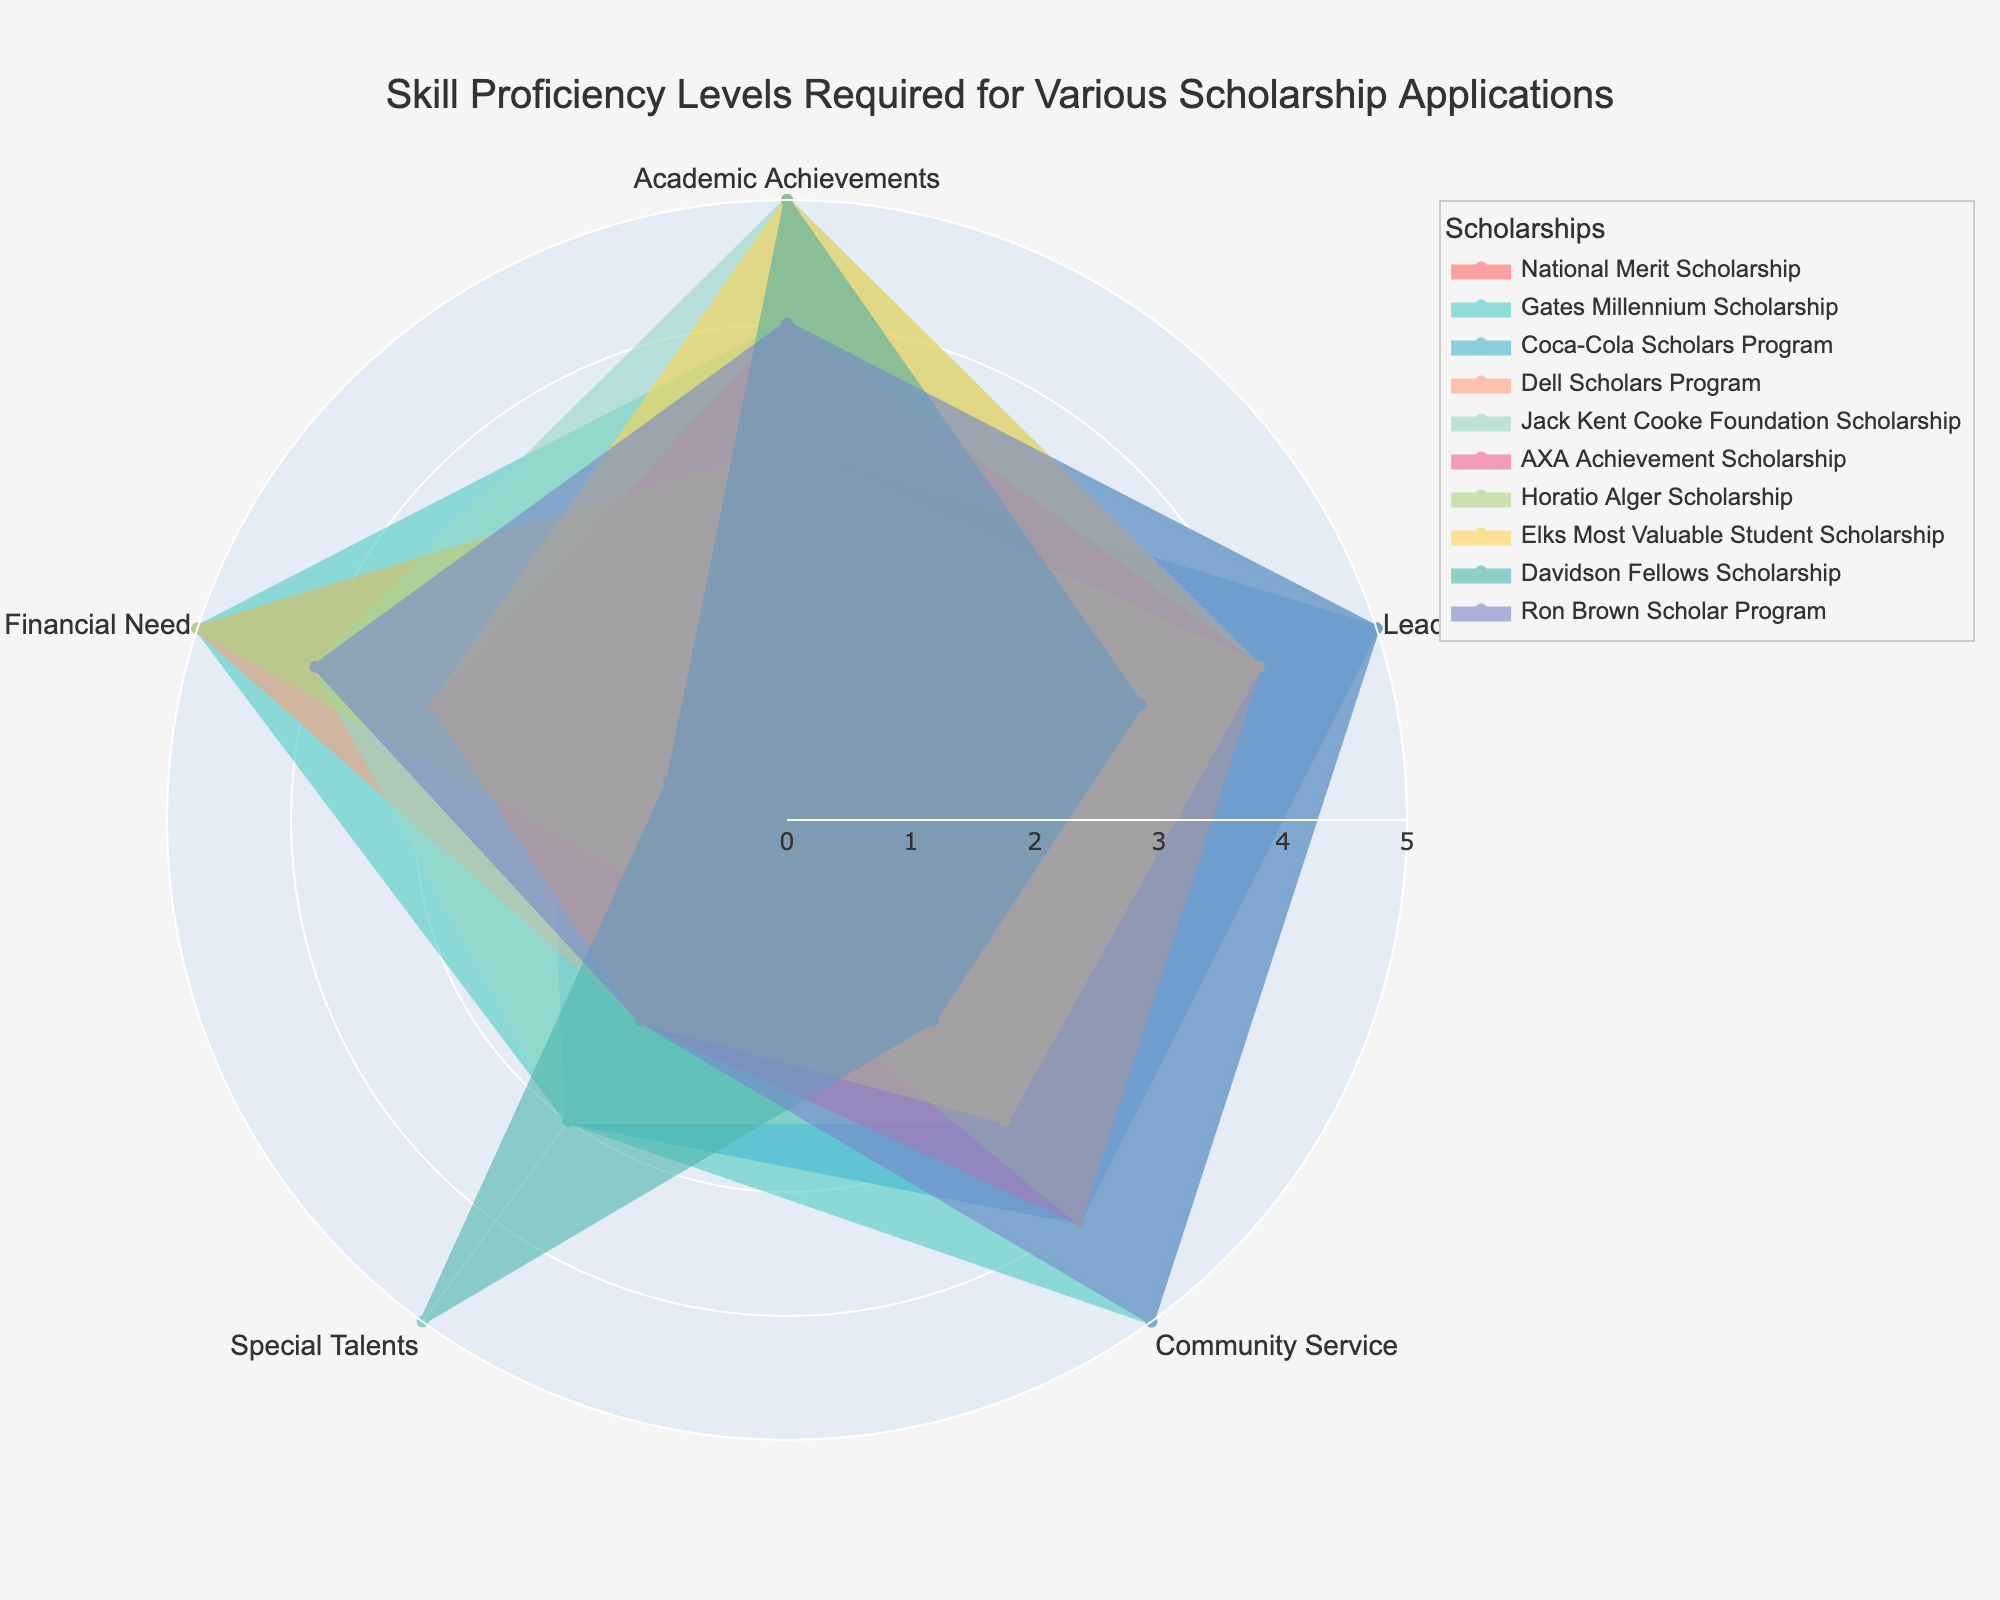What is the title of the radar chart? The title appears at the top of the chart and summarizes the data being presented. By looking at the top part of the radar chart, you can easily see the title.
Answer: Skill Proficiency Levels Required for Various Scholarship Applications Which scholarship requires the highest proficiency level in Leadership? To find this, look at the 'Leadership' axis on the radar chart and see which scholarship has the largest value (i.e., the furthest distance from the center) along that axis.
Answer: Gates Millennium Scholarship Which category shows the lowest proficiency requirement for the National Merit Scholarship? Look at the radial lines of the radar chart for the National Merit Scholarship. Identify the segment with the least distance from the center.
Answer: Special Talents, Financial Need How many scholarships require a proficiency level of 5 in Community Service? Check the 'Community Service' axis and count how many radar lines reach the highest point (level 5) for Community Service proficiency.
Answer: 2 What is the average proficiency level required for the Dell Scholars Program across all categories? Sum the proficiency levels for the Dell Scholars Program (3 + 4 + 3 + 2 + 5) and divide by the number of categories (5) to get the average.
Answer: 3.4 Which scholarship shows the most balanced proficiency requirements across all categories? Look for the radar plot where the shape looks the most even and symmetric, indicating similar proficiency levels across all categories.
Answer: Coca-Cola Scholars Program Compare the proficiency levels in Special Talents required by the Davidson Fellows Scholarship and Gates Millennium Scholarship. Which is higher? On the radar chart, compare the points along the 'Special Talents' axis for Davidson Fellows Scholarship and Gates Millennium Scholarship to see which one is farther from the center.
Answer: Davidson Fellows Scholarship Which two scholarships have the same proficiency level in Financial Need? Look at the 'Financial Need' axis and find two radar lines that end at the same level.
Answer: Dell Scholars Program, Horatio Alger Scholarship In how many categories does the AXA Achievement Scholarship require a proficiency level of 4? Check the radar plot for the AXA Achievement Scholarship and count the segments that extend to level 4.
Answer: 3 Which scholarship requires the highest overall proficiency in more categories compared to others? Identify the scholarship that has the most categories with proficiency levels closer to 5, comparing distances from the center of the radar chart for each category.
Answer: Gates Millennium Scholarship 